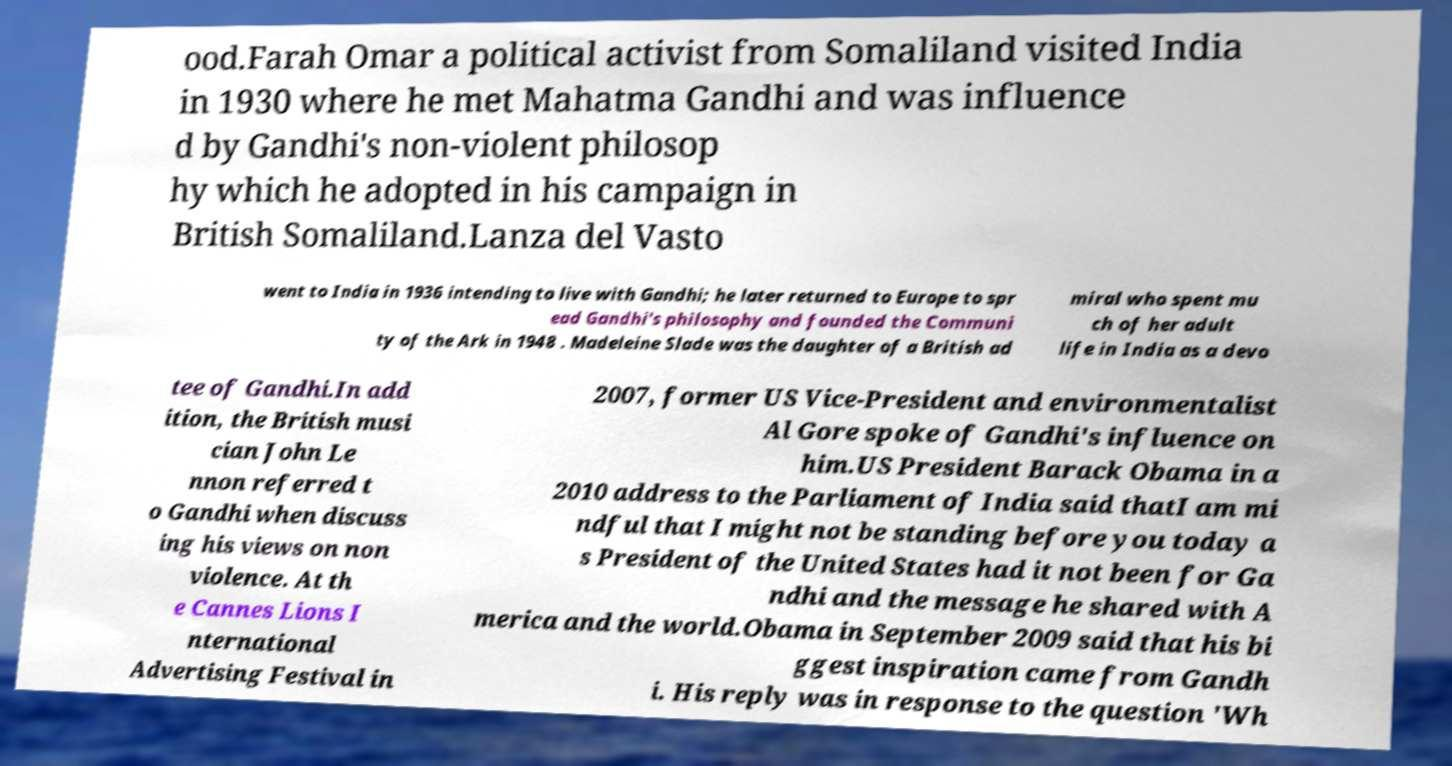What messages or text are displayed in this image? I need them in a readable, typed format. ood.Farah Omar a political activist from Somaliland visited India in 1930 where he met Mahatma Gandhi and was influence d by Gandhi's non-violent philosop hy which he adopted in his campaign in British Somaliland.Lanza del Vasto went to India in 1936 intending to live with Gandhi; he later returned to Europe to spr ead Gandhi's philosophy and founded the Communi ty of the Ark in 1948 . Madeleine Slade was the daughter of a British ad miral who spent mu ch of her adult life in India as a devo tee of Gandhi.In add ition, the British musi cian John Le nnon referred t o Gandhi when discuss ing his views on non violence. At th e Cannes Lions I nternational Advertising Festival in 2007, former US Vice-President and environmentalist Al Gore spoke of Gandhi's influence on him.US President Barack Obama in a 2010 address to the Parliament of India said thatI am mi ndful that I might not be standing before you today a s President of the United States had it not been for Ga ndhi and the message he shared with A merica and the world.Obama in September 2009 said that his bi ggest inspiration came from Gandh i. His reply was in response to the question 'Wh 